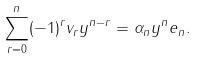<formula> <loc_0><loc_0><loc_500><loc_500>\sum _ { r = 0 } ^ { n } ( - 1 ) ^ { r } v _ { r } y ^ { n - r } = \alpha _ { n } y ^ { n } e _ { n } .</formula> 